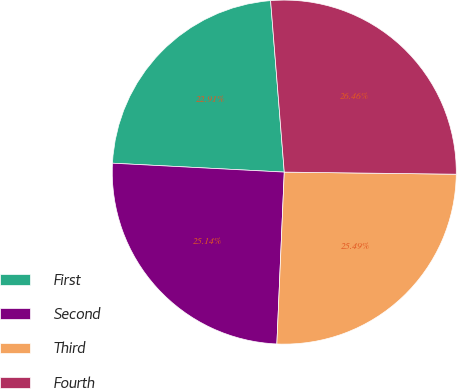Convert chart to OTSL. <chart><loc_0><loc_0><loc_500><loc_500><pie_chart><fcel>First<fcel>Second<fcel>Third<fcel>Fourth<nl><fcel>22.91%<fcel>25.14%<fcel>25.49%<fcel>26.46%<nl></chart> 